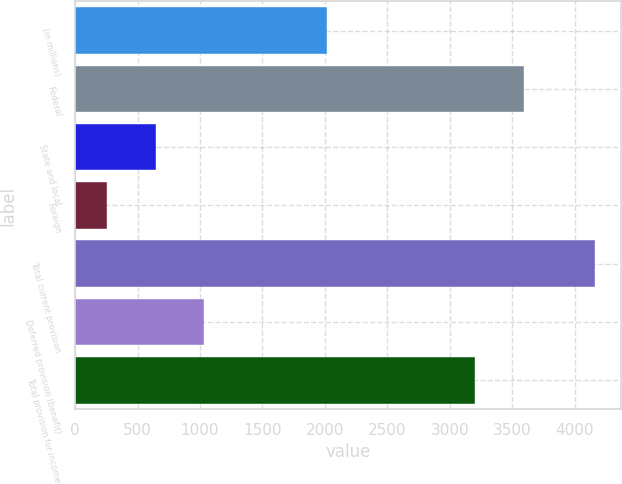Convert chart to OTSL. <chart><loc_0><loc_0><loc_500><loc_500><bar_chart><fcel>(in millions)<fcel>Federal<fcel>State and local<fcel>Foreign<fcel>Total current provision<fcel>Deferred provision (benefit)<fcel>Total provision for income<nl><fcel>2017<fcel>3597<fcel>645.1<fcel>254<fcel>4165<fcel>1036.2<fcel>3200<nl></chart> 